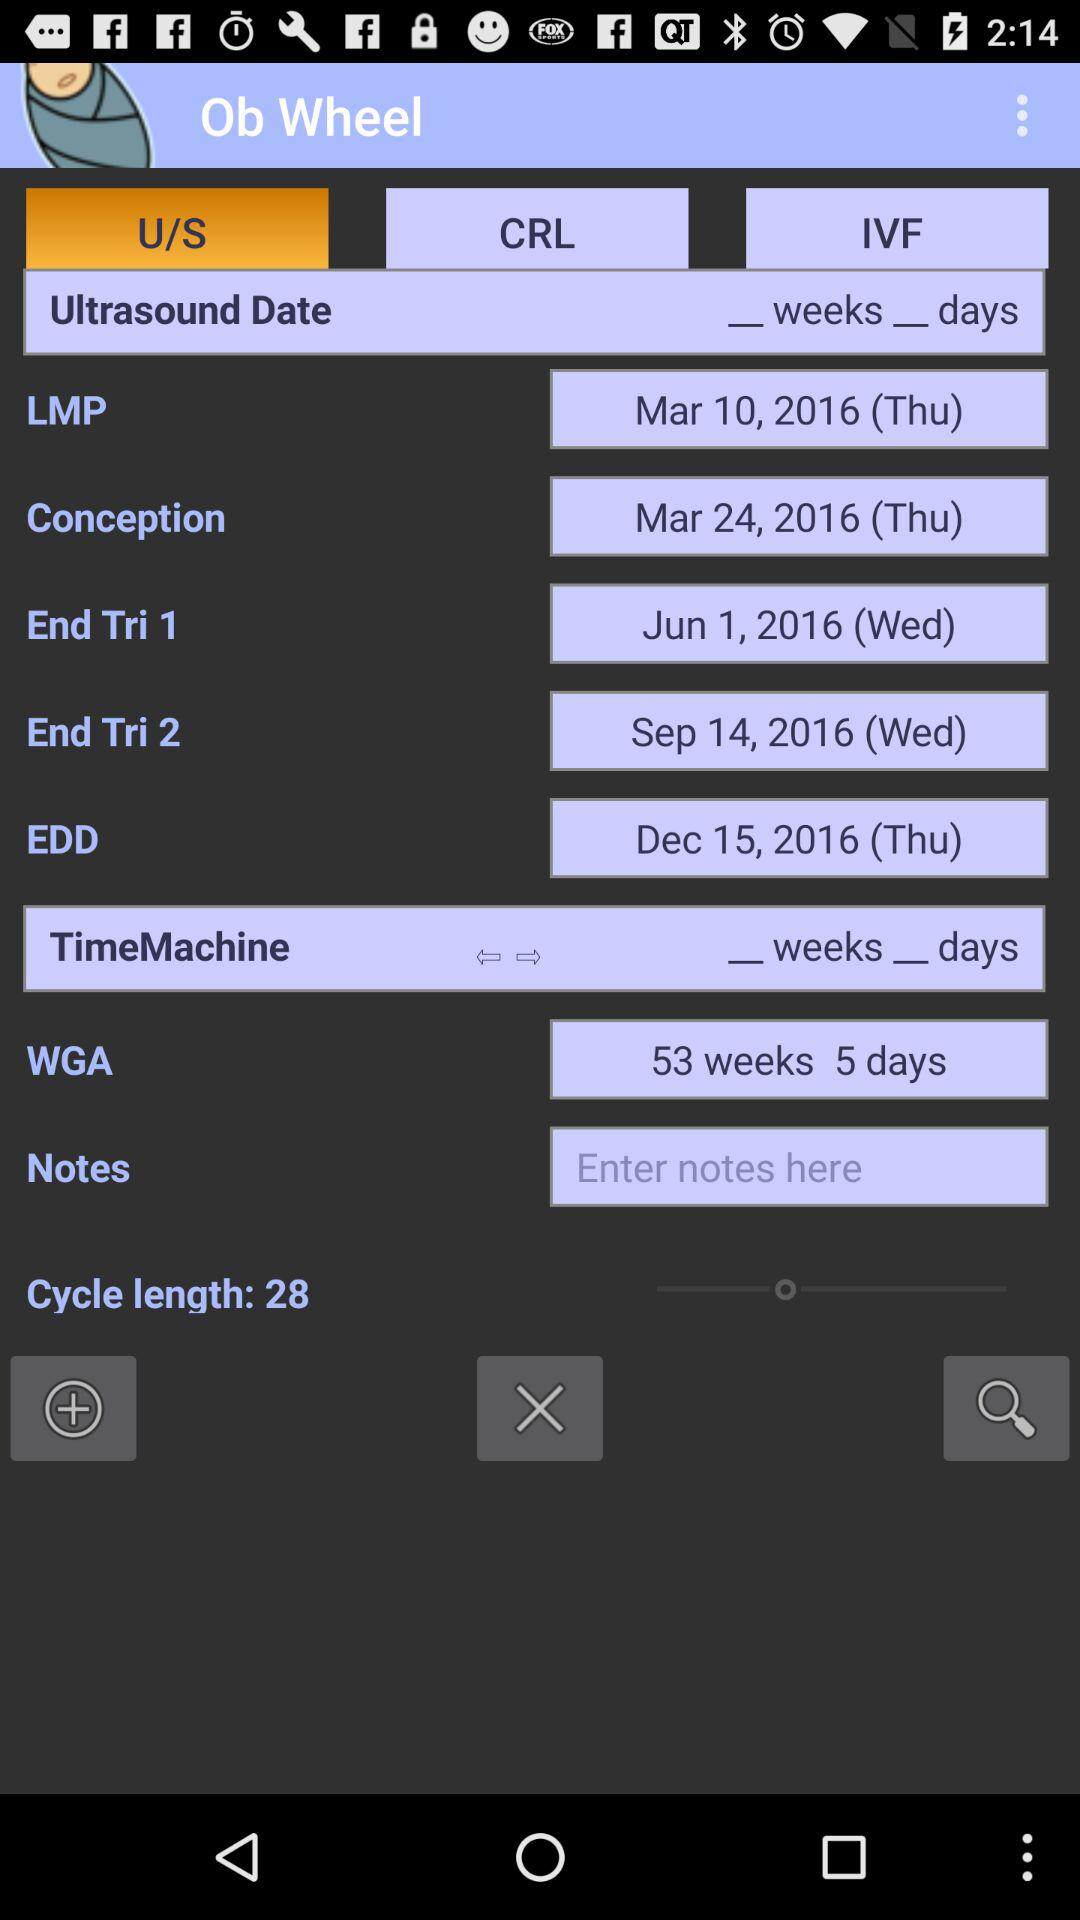What is the EDD? The EDD is Thursday, December 15, 2016. 